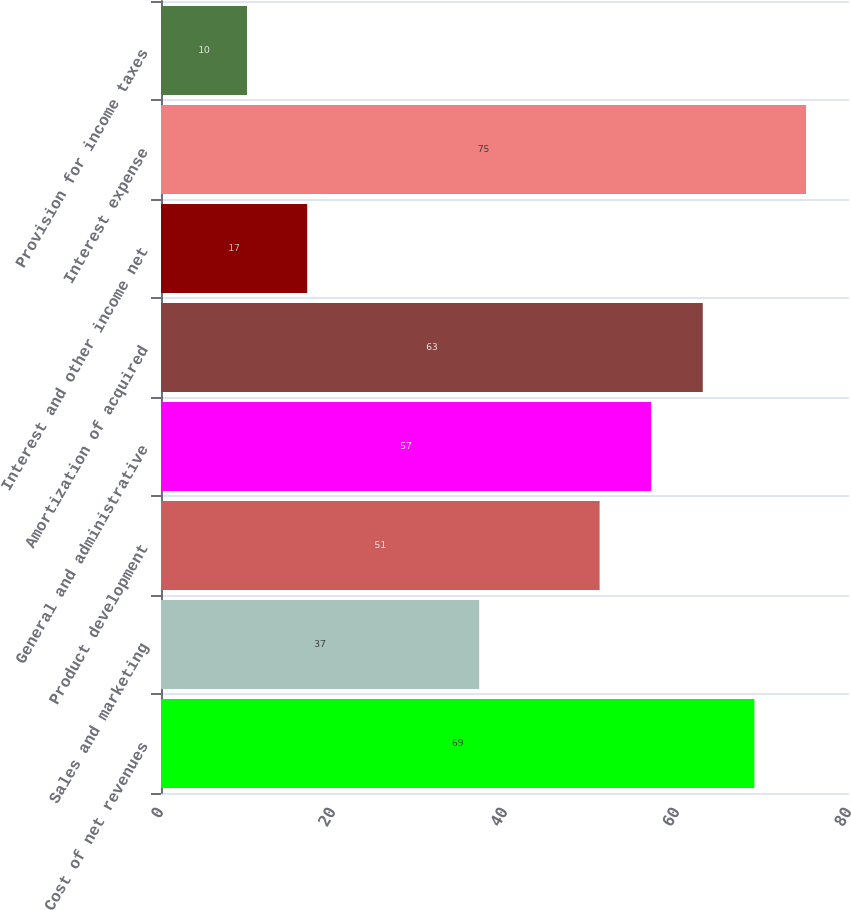Convert chart. <chart><loc_0><loc_0><loc_500><loc_500><bar_chart><fcel>Cost of net revenues<fcel>Sales and marketing<fcel>Product development<fcel>General and administrative<fcel>Amortization of acquired<fcel>Interest and other income net<fcel>Interest expense<fcel>Provision for income taxes<nl><fcel>69<fcel>37<fcel>51<fcel>57<fcel>63<fcel>17<fcel>75<fcel>10<nl></chart> 